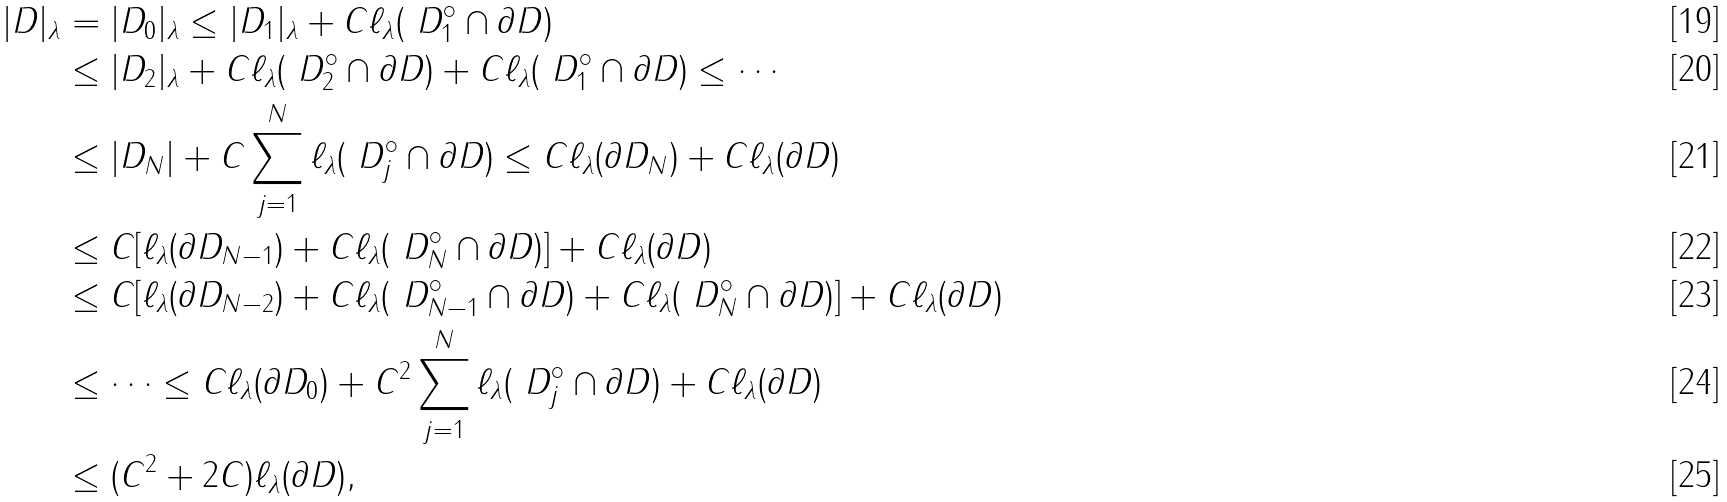Convert formula to latex. <formula><loc_0><loc_0><loc_500><loc_500>| D | _ { \lambda } & = | D _ { 0 } | _ { \lambda } \leq | D _ { 1 } | _ { \lambda } + C \ell _ { \lambda } ( \ D _ { 1 } ^ { \circ } \cap \partial D ) \\ & \leq | D _ { 2 } | _ { \lambda } + C \ell _ { \lambda } ( \ D _ { 2 } ^ { \circ } \cap \partial D ) + C \ell _ { \lambda } ( \ D _ { 1 } ^ { \circ } \cap \partial D ) \leq \cdots \\ & \leq | D _ { N } | + C \sum _ { j = 1 } ^ { N } \ell _ { \lambda } ( \ D _ { j } ^ { \circ } \cap \partial D ) \leq C \ell _ { \lambda } ( \partial D _ { N } ) + C \ell _ { \lambda } ( \partial D ) \\ & \leq C [ \ell _ { \lambda } ( \partial D _ { N - 1 } ) + C \ell _ { \lambda } ( \ D _ { N } ^ { \circ } \cap \partial D ) ] + C \ell _ { \lambda } ( \partial D ) \\ & \leq C [ \ell _ { \lambda } ( \partial D _ { N - 2 } ) + C \ell _ { \lambda } ( \ D _ { N - 1 } ^ { \circ } \cap \partial D ) + C \ell _ { \lambda } ( \ D _ { N } ^ { \circ } \cap \partial D ) ] + C \ell _ { \lambda } ( \partial D ) \\ & \leq \cdots \leq C \ell _ { \lambda } ( \partial D _ { 0 } ) + C ^ { 2 } \sum _ { j = 1 } ^ { N } \ell _ { \lambda } ( \ D _ { j } ^ { \circ } \cap \partial D ) + C \ell _ { \lambda } ( \partial D ) \\ & \leq ( C ^ { 2 } + 2 C ) \ell _ { \lambda } ( \partial D ) ,</formula> 